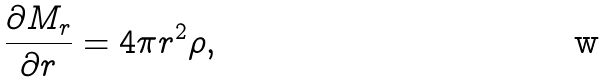Convert formula to latex. <formula><loc_0><loc_0><loc_500><loc_500>\frac { \partial M _ { r } } { \partial r } = 4 \pi r ^ { 2 } \rho ,</formula> 